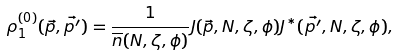Convert formula to latex. <formula><loc_0><loc_0><loc_500><loc_500>\rho _ { 1 } ^ { ( 0 ) } ( \vec { p } , \vec { p ^ { \prime } } ) = \frac { 1 } { \overline { n } ( N , \zeta , \phi ) } J ( \vec { p } , N , \zeta , \phi ) J ^ { * } ( \vec { p ^ { \prime } } , N , \zeta , \phi ) ,</formula> 